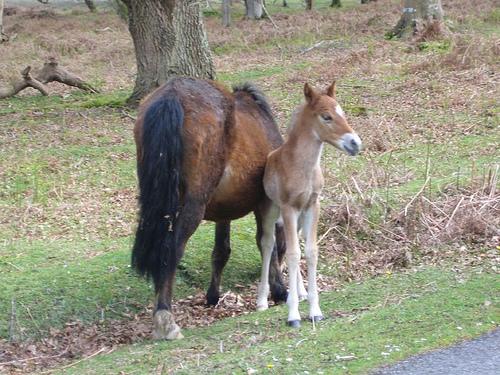Does this look like a mama and foal?
Keep it brief. Yes. What does the smaller horse like to eat?
Write a very short answer. Grass. What kind of fur does the adult have?
Short answer required. Thick. 